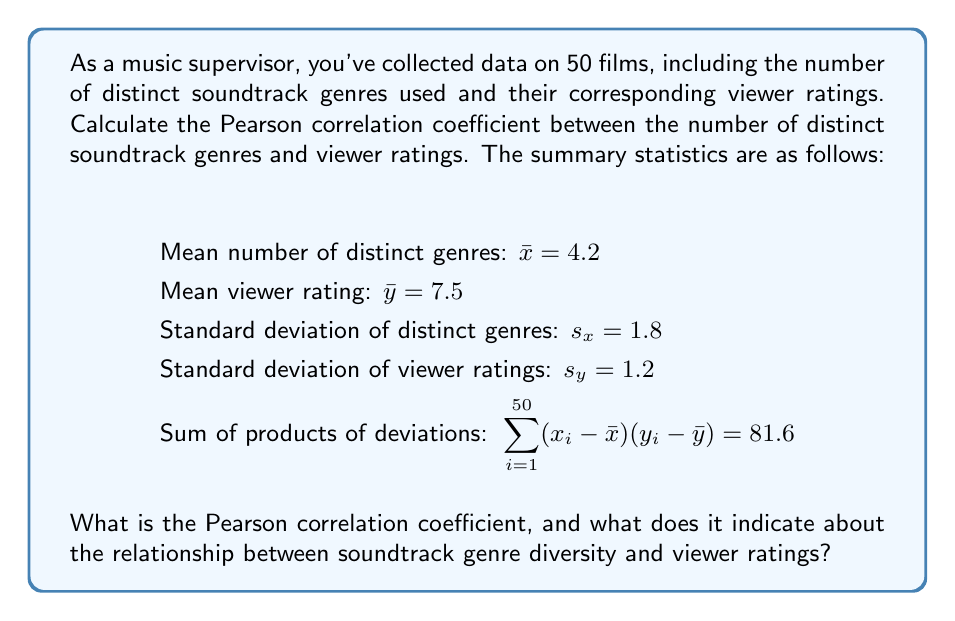Teach me how to tackle this problem. To calculate the Pearson correlation coefficient, we'll use the formula:

$$r = \frac{\sum_{i=1}^{n} (x_i - \bar{x})(y_i - \bar{y})}{(n-1)s_x s_y}$$

Where:
$n$ = number of films = 50
$\sum_{i=1}^{50} (x_i - \bar{x})(y_i - \bar{y}) = 81.6$ (given)
$s_x = 1.8$ (given)
$s_y = 1.2$ (given)

Let's substitute these values into the formula:

$$r = \frac{81.6}{(50-1)(1.8)(1.2)}$$

$$r = \frac{81.6}{(49)(1.8)(1.2)}$$

$$r = \frac{81.6}{105.84}$$

$$r \approx 0.7710$$

The Pearson correlation coefficient ranges from -1 to 1, where:
- 1 indicates a perfect positive linear correlation
- 0 indicates no linear correlation
- -1 indicates a perfect negative linear correlation

A value of 0.7710 suggests a strong positive correlation between the number of distinct soundtrack genres and viewer ratings.

This means that as the diversity of soundtrack genres increases, there tends to be an increase in viewer ratings. However, correlation does not imply causation, so we cannot conclude that increased genre diversity directly causes higher ratings.
Answer: The Pearson correlation coefficient is approximately 0.7710, indicating a strong positive correlation between soundtrack genre diversity and viewer ratings. 